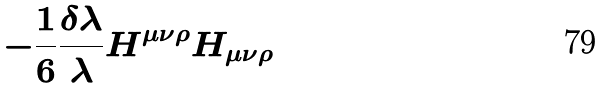Convert formula to latex. <formula><loc_0><loc_0><loc_500><loc_500>- \frac { 1 } { 6 } \frac { \delta \lambda } { \lambda } H ^ { \mu \nu \rho } H _ { \mu \nu \rho }</formula> 